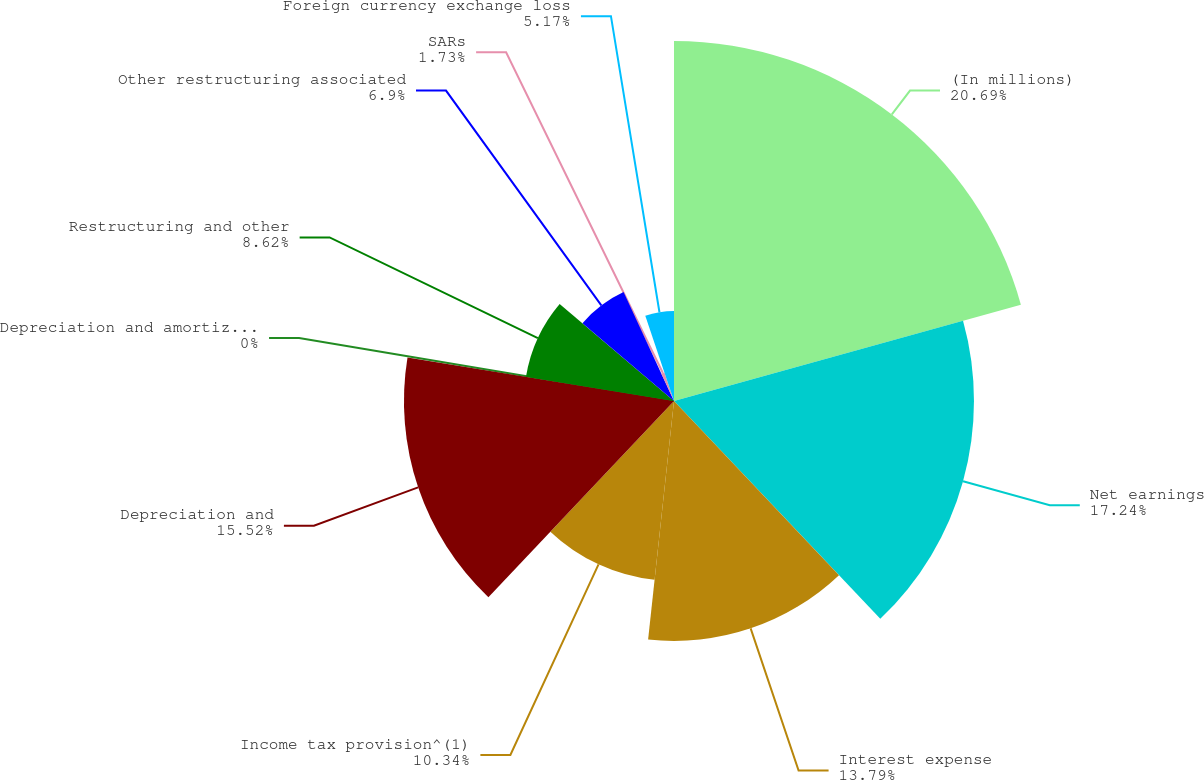Convert chart to OTSL. <chart><loc_0><loc_0><loc_500><loc_500><pie_chart><fcel>(In millions)<fcel>Net earnings<fcel>Interest expense<fcel>Income tax provision^(1)<fcel>Depreciation and<fcel>Depreciation and amortization<fcel>Restructuring and other<fcel>Other restructuring associated<fcel>SARs<fcel>Foreign currency exchange loss<nl><fcel>20.69%<fcel>17.24%<fcel>13.79%<fcel>10.34%<fcel>15.52%<fcel>0.0%<fcel>8.62%<fcel>6.9%<fcel>1.73%<fcel>5.17%<nl></chart> 